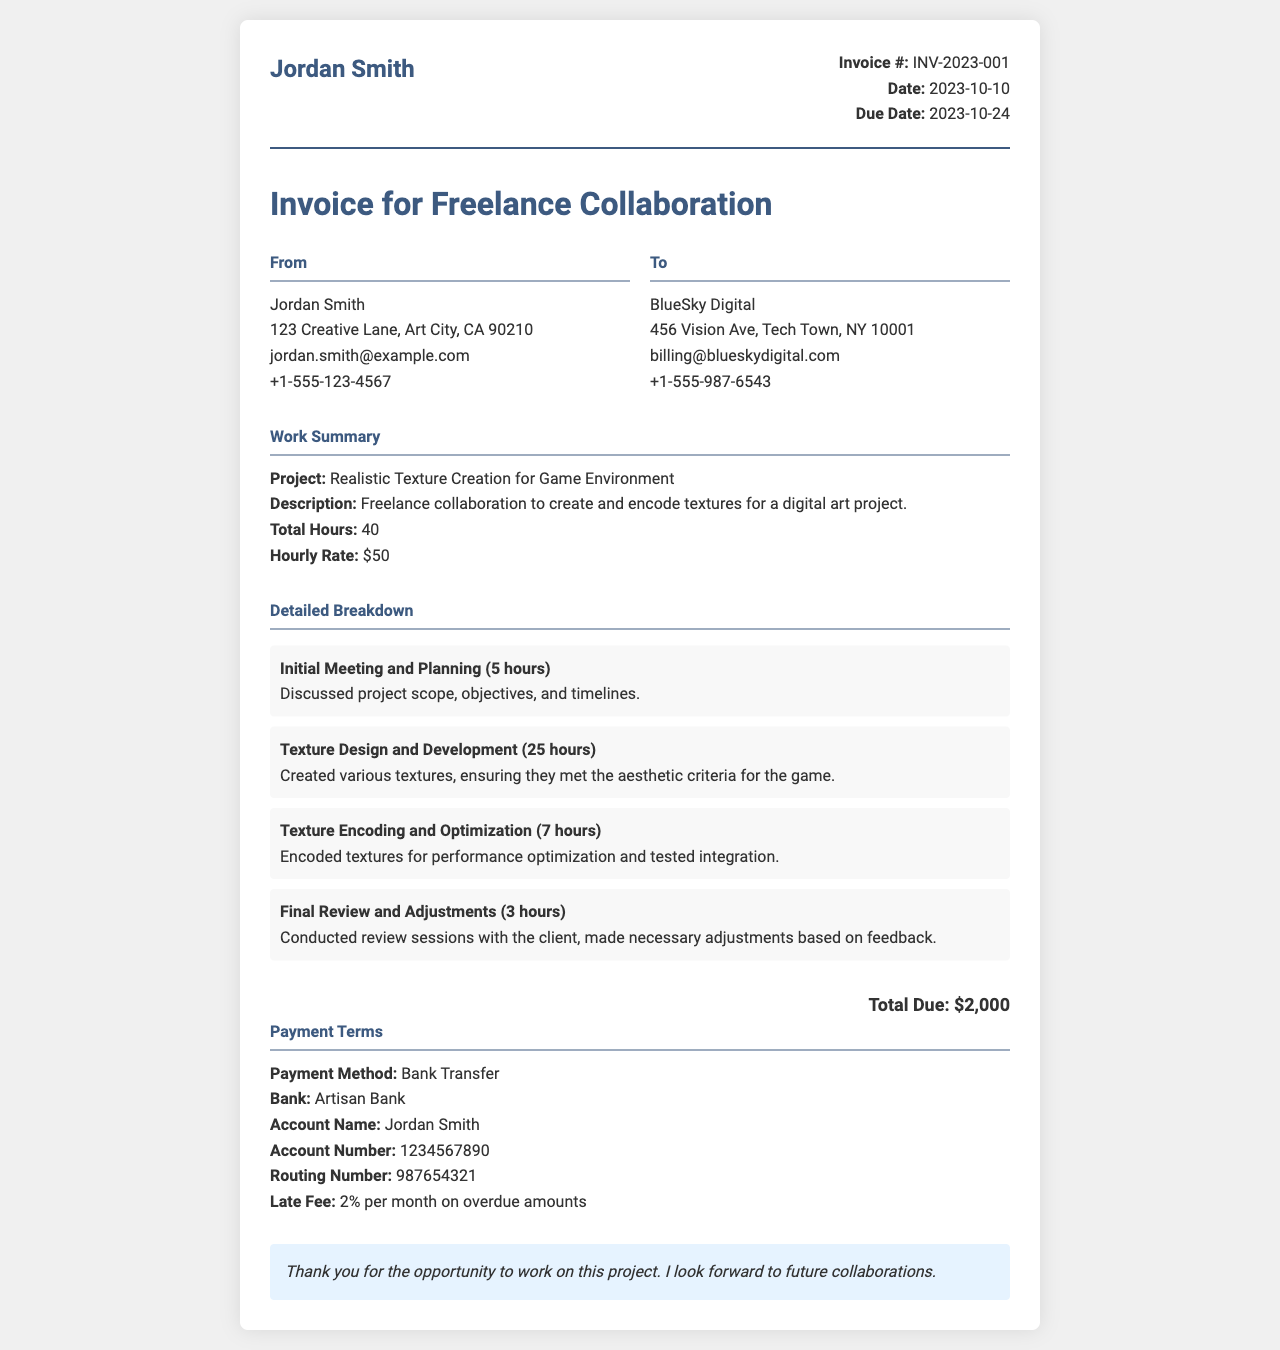What is the invoice number? The invoice number is mentioned near the top of the document.
Answer: INV-2023-001 What is the total hours worked? The total hours worked is detailed in the Work Summary section.
Answer: 40 What is the hourly rate? The hourly rate is stated in the Work Summary section.
Answer: $50 How much is the total due? The total due is specified at the end of the invoice.
Answer: $2000 What payment method is accepted? The payment method is listed under the Payment Terms section.
Answer: Bank Transfer Who is the client for this invoice? The client's name is mentioned in the document's To section.
Answer: BlueSky Digital What is the due date for the invoice? The due date is located in the invoice details portion.
Answer: 2023-10-24 How many hours were spent on Texture Design and Development? The hours for this task are mentioned in the Detailed Breakdown of work.
Answer: 25 hours What is the late fee percentage? The late fee percentage can be found in the Payment Terms section.
Answer: 2% per month 